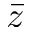Convert formula to latex. <formula><loc_0><loc_0><loc_500><loc_500>\bar { z }</formula> 